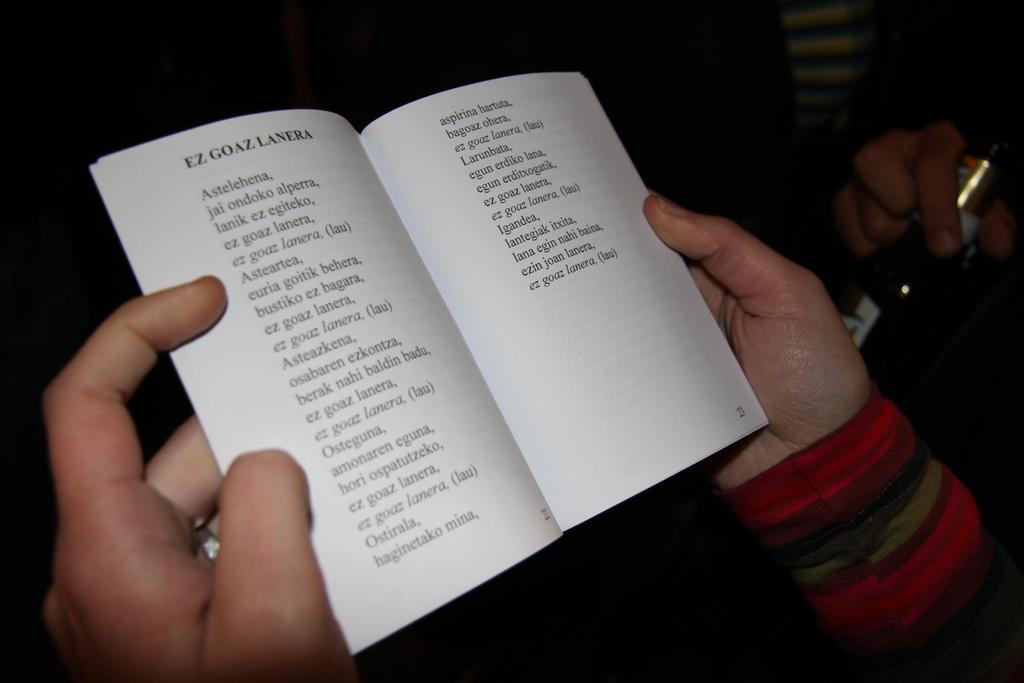Provide a one-sentence caption for the provided image. A person holding a thin book to a page with list of foreign words. 